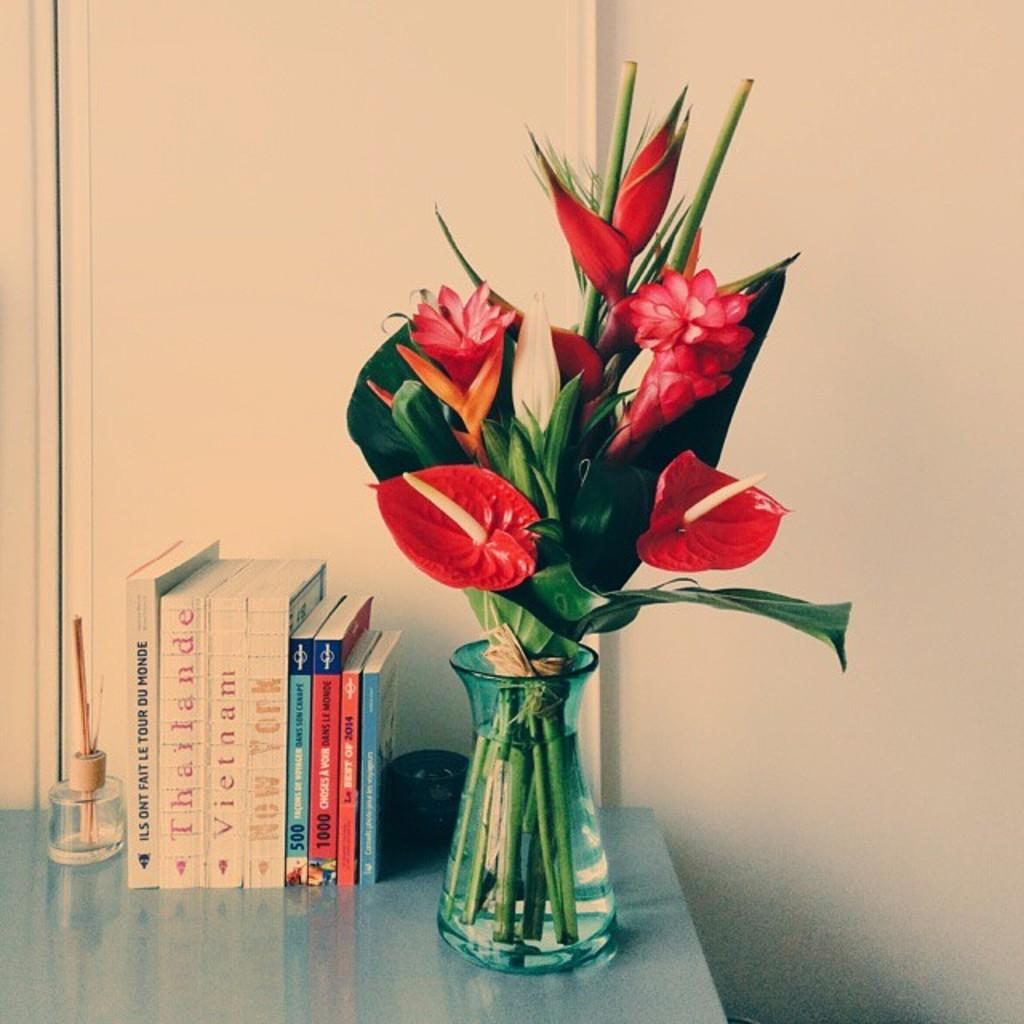What can be seen in the vase in the image? There is a flower vase with flowers and leaves in the image. What else is present in the image besides the flower vase? There are books and a bottle with sticks in the image. What is the object on the table in the image? The object on the table is not specified, but it is mentioned that there is an object on the table. What is visible in the background of the image? There is a wall in the background of the image. What type of car is parked in front of the wall in the image? There is no car present in the image; it only features a flower vase, books, a bottle with sticks, an object on the table, and a wall in the background. What territory or border is depicted in the image? The image does not depict any territory or border; it focuses on objects on a table and a wall in the background. 